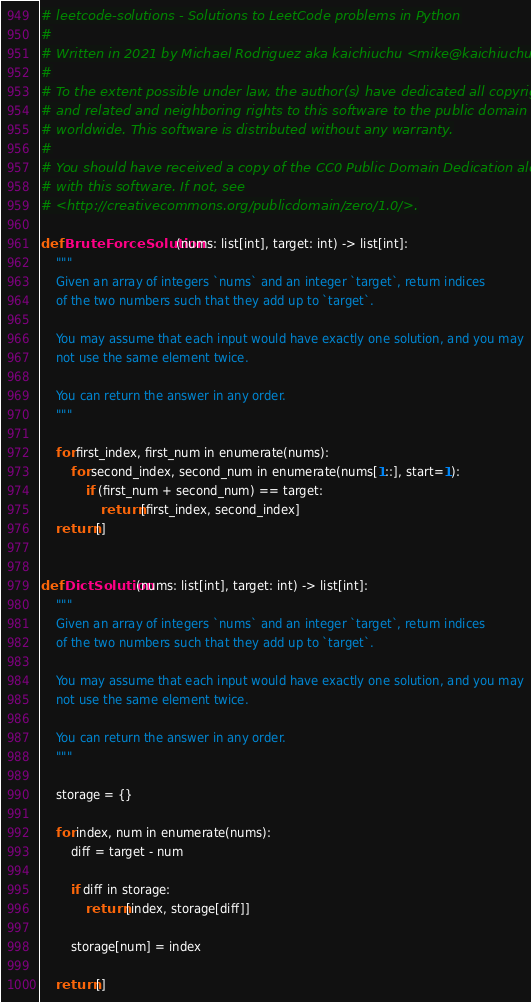Convert code to text. <code><loc_0><loc_0><loc_500><loc_500><_Python_># leetcode-solutions - Solutions to LeetCode problems in Python
#
# Written in 2021 by Michael Rodriguez aka kaichiuchu <mike@kaichiuchu.dev>
#
# To the extent possible under law, the author(s) have dedicated all copyright
# and related and neighboring rights to this software to the public domain
# worldwide. This software is distributed without any warranty.
#
# You should have received a copy of the CC0 Public Domain Dedication along
# with this software. If not, see
# <http://creativecommons.org/publicdomain/zero/1.0/>.

def BruteForceSolution(nums: list[int], target: int) -> list[int]:
    """
    Given an array of integers `nums` and an integer `target`, return indices
    of the two numbers such that they add up to `target`.

    You may assume that each input would have exactly one solution, and you may
    not use the same element twice.

    You can return the answer in any order.
    """

    for first_index, first_num in enumerate(nums):
        for second_index, second_num in enumerate(nums[1::], start=1):
            if (first_num + second_num) == target:
                return [first_index, second_index]
    return []


def DictSolution(nums: list[int], target: int) -> list[int]:
    """
    Given an array of integers `nums` and an integer `target`, return indices
    of the two numbers such that they add up to `target`.

    You may assume that each input would have exactly one solution, and you may
    not use the same element twice.

    You can return the answer in any order.
    """

    storage = {}

    for index, num in enumerate(nums):
        diff = target - num

        if diff in storage:
            return [index, storage[diff]]

        storage[num] = index

    return []
</code> 